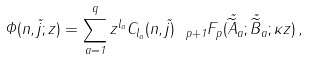Convert formula to latex. <formula><loc_0><loc_0><loc_500><loc_500>\Phi ( n , \vec { j } ; z ) = \sum _ { a = 1 } ^ { q } z ^ { l _ { a } } C _ { l _ { a } } ( n , \vec { j } ) { \ } _ { p + 1 } F _ { p } ( \vec { \widetilde { A } } _ { a } ; \vec { \widetilde { B } } _ { a } ; \kappa z ) \, ,</formula> 